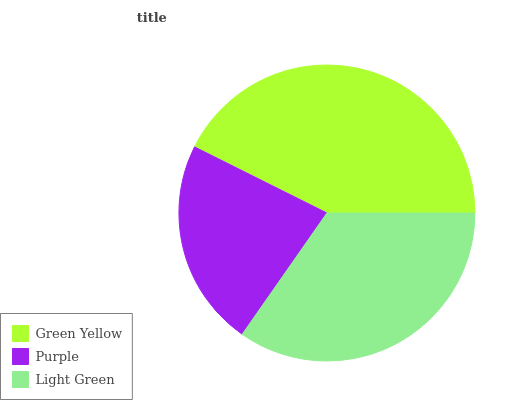Is Purple the minimum?
Answer yes or no. Yes. Is Green Yellow the maximum?
Answer yes or no. Yes. Is Light Green the minimum?
Answer yes or no. No. Is Light Green the maximum?
Answer yes or no. No. Is Light Green greater than Purple?
Answer yes or no. Yes. Is Purple less than Light Green?
Answer yes or no. Yes. Is Purple greater than Light Green?
Answer yes or no. No. Is Light Green less than Purple?
Answer yes or no. No. Is Light Green the high median?
Answer yes or no. Yes. Is Light Green the low median?
Answer yes or no. Yes. Is Purple the high median?
Answer yes or no. No. Is Green Yellow the low median?
Answer yes or no. No. 